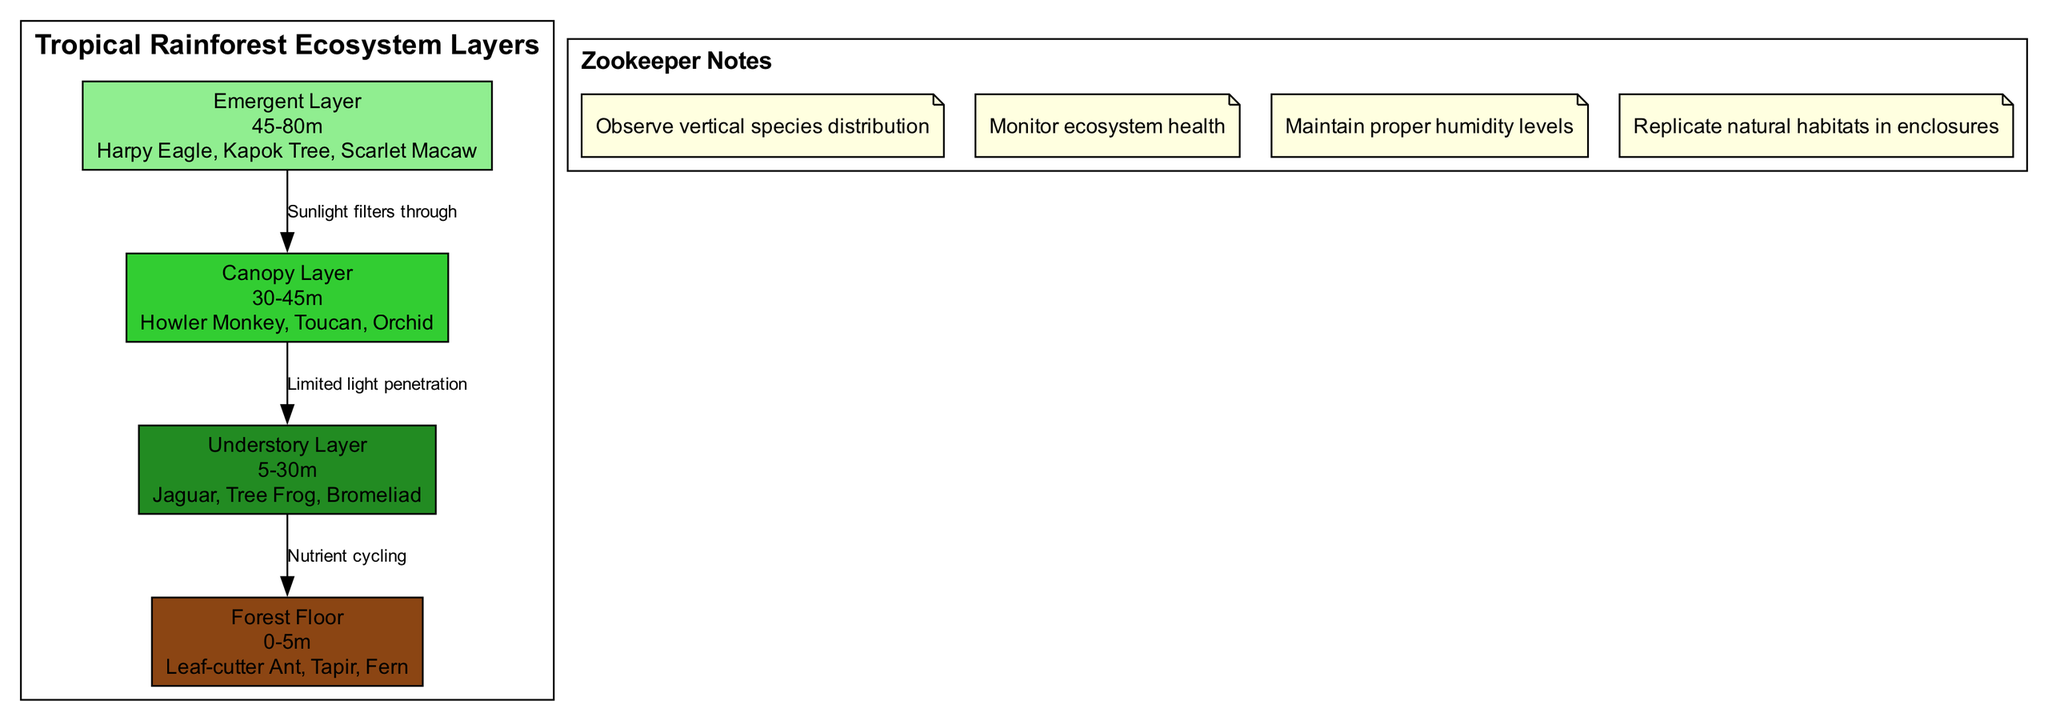What is the height range of the Emergent Layer? The diagram indicates that the height range of the Emergent Layer is between 45 and 80 meters. This is seen directly in the label associated with the Emergent Layer node.
Answer: 45-80m Which species can be found in the Canopy Layer? The Canopy Layer includes species listed in its node, which are Howler Monkey, Toucan, and Orchid. These species are directly connected to the Canopy Layer as per the diagram.
Answer: Howler Monkey, Toucan, Orchid What type of relationship exists between the Canopy Layer and the Understory Layer? The diagram specifies a relationship labeled "Limited light penetration" connecting the Canopy Layer to the Understory Layer. This indicates that the light affecting the Understory is limited by the Canopy above.
Answer: Limited light penetration How many layers are represented in the diagram? By counting the layers shown in the diagram—Emergent Layer, Canopy Layer, Understory Layer, and Forest Floor—we find a total of four distinct layers depicted.
Answer: 4 What is the role of the Forest Floor in the ecosystem, according to the connections? The diagram shows a connection from the Understory Layer to the Forest Floor labeled "Nutrient cycling," indicating that one of its roles is involved in the cycling of nutrients within the ecosystem.
Answer: Nutrient cycling Which species occupies the Forest Floor? The species listed under the Forest Floor layer include Leaf-cutter Ant, Tapir, and Fern, directly referenced in the diagram's Forest Floor node.
Answer: Leaf-cutter Ant, Tapir, Fern Which layer receives the most sunlight? The diagram indicates that the Emergent Layer is at the highest point, thus it receives the most sunlight because it is above the other layers and is exposed to direct sunlight.
Answer: Emergent Layer What are the zookeeper notes related to ecosystem maintenance? The zookeeper notes encourage observing vertical species distribution, monitoring ecosystem health, maintaining proper humidity levels, and replicating natural habitats in enclosures, all aimed at effective care of the ecosystem.
Answer: Observe vertical species distribution, monitor ecosystem health, maintain proper humidity levels, replicate natural habitats in enclosures 